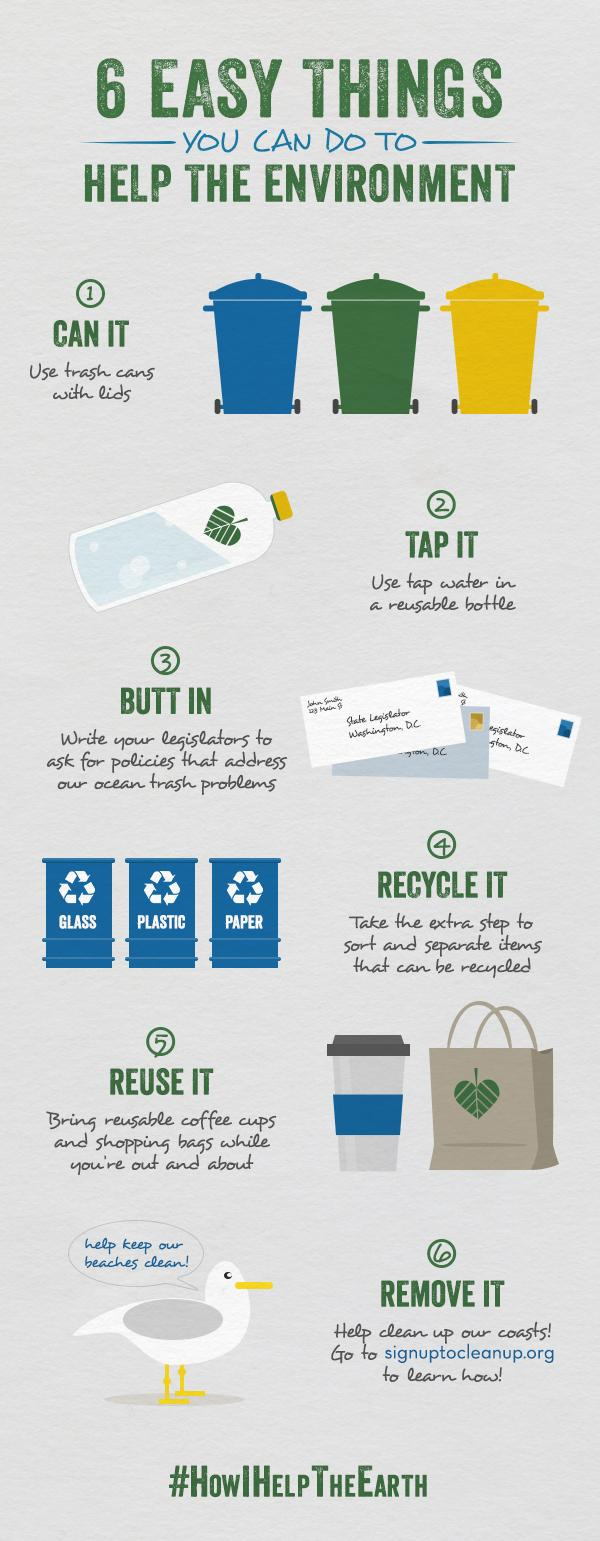Mention a couple of crucial points in this snapshot. This infographic contains 1 coffee cup. There are three trash cans depicted in this infographic. 